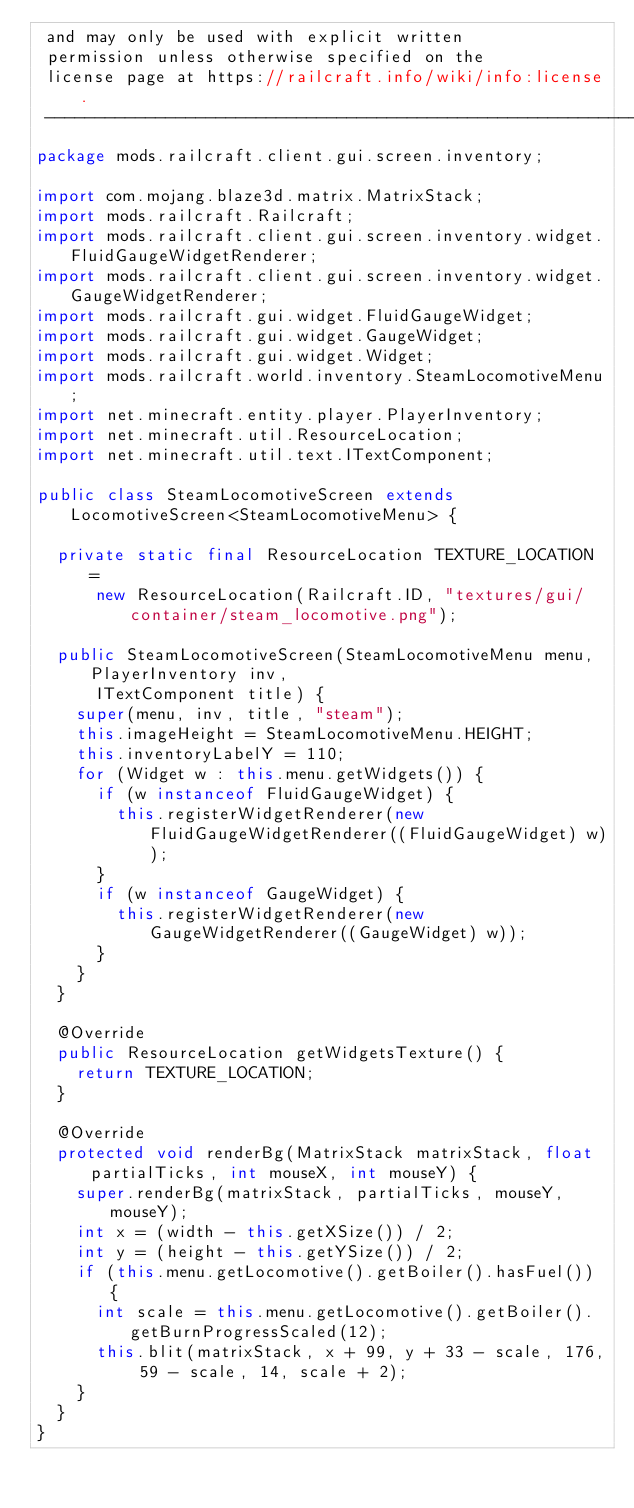<code> <loc_0><loc_0><loc_500><loc_500><_Java_> and may only be used with explicit written
 permission unless otherwise specified on the
 license page at https://railcraft.info/wiki/info:license.
 -----------------------------------------------------------------------------*/
package mods.railcraft.client.gui.screen.inventory;

import com.mojang.blaze3d.matrix.MatrixStack;
import mods.railcraft.Railcraft;
import mods.railcraft.client.gui.screen.inventory.widget.FluidGaugeWidgetRenderer;
import mods.railcraft.client.gui.screen.inventory.widget.GaugeWidgetRenderer;
import mods.railcraft.gui.widget.FluidGaugeWidget;
import mods.railcraft.gui.widget.GaugeWidget;
import mods.railcraft.gui.widget.Widget;
import mods.railcraft.world.inventory.SteamLocomotiveMenu;
import net.minecraft.entity.player.PlayerInventory;
import net.minecraft.util.ResourceLocation;
import net.minecraft.util.text.ITextComponent;

public class SteamLocomotiveScreen extends LocomotiveScreen<SteamLocomotiveMenu> {

  private static final ResourceLocation TEXTURE_LOCATION =
      new ResourceLocation(Railcraft.ID, "textures/gui/container/steam_locomotive.png");

  public SteamLocomotiveScreen(SteamLocomotiveMenu menu, PlayerInventory inv,
      ITextComponent title) {
    super(menu, inv, title, "steam");
    this.imageHeight = SteamLocomotiveMenu.HEIGHT;
    this.inventoryLabelY = 110;
    for (Widget w : this.menu.getWidgets()) {
      if (w instanceof FluidGaugeWidget) {
        this.registerWidgetRenderer(new FluidGaugeWidgetRenderer((FluidGaugeWidget) w));
      }
      if (w instanceof GaugeWidget) {
        this.registerWidgetRenderer(new GaugeWidgetRenderer((GaugeWidget) w));
      }
    }
  }

  @Override
  public ResourceLocation getWidgetsTexture() {
    return TEXTURE_LOCATION;
  }

  @Override
  protected void renderBg(MatrixStack matrixStack, float partialTicks, int mouseX, int mouseY) {
    super.renderBg(matrixStack, partialTicks, mouseY, mouseY);
    int x = (width - this.getXSize()) / 2;
    int y = (height - this.getYSize()) / 2;
    if (this.menu.getLocomotive().getBoiler().hasFuel()) {
      int scale = this.menu.getLocomotive().getBoiler().getBurnProgressScaled(12);
      this.blit(matrixStack, x + 99, y + 33 - scale, 176, 59 - scale, 14, scale + 2);
    }
  }
}
</code> 